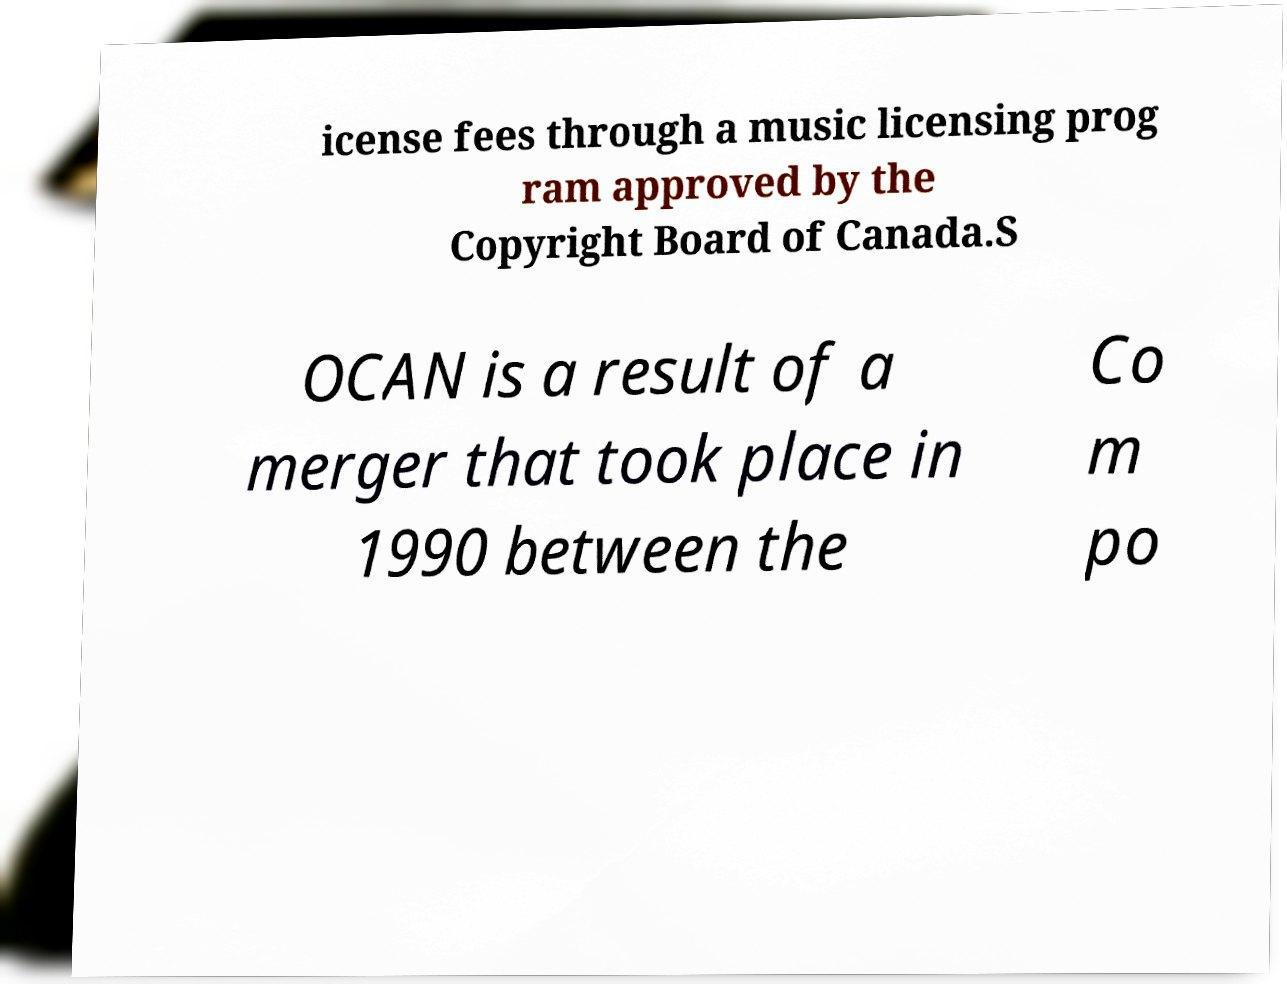Can you read and provide the text displayed in the image?This photo seems to have some interesting text. Can you extract and type it out for me? icense fees through a music licensing prog ram approved by the Copyright Board of Canada.S OCAN is a result of a merger that took place in 1990 between the Co m po 